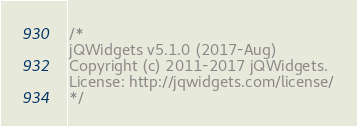Convert code to text. <code><loc_0><loc_0><loc_500><loc_500><_JavaScript_>/*
jQWidgets v5.1.0 (2017-Aug)
Copyright (c) 2011-2017 jQWidgets.
License: http://jqwidgets.com/license/
*/</code> 